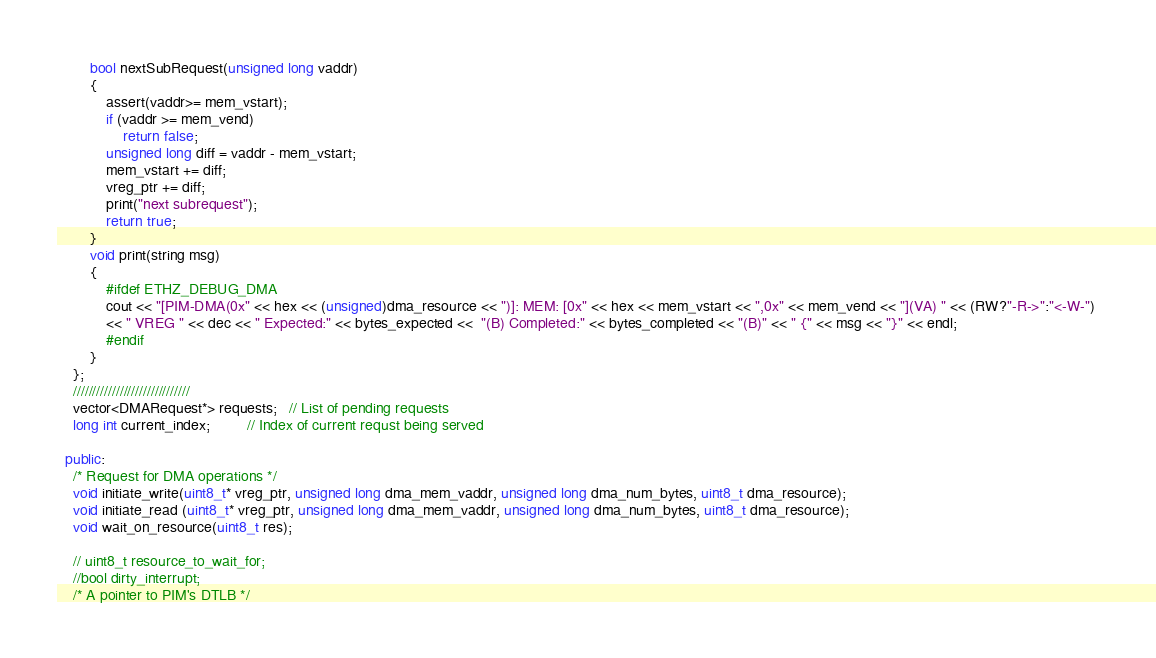Convert code to text. <code><loc_0><loc_0><loc_500><loc_500><_C++_>        bool nextSubRequest(unsigned long vaddr)
        {
            assert(vaddr>= mem_vstart);
            if (vaddr >= mem_vend)
                return false;
            unsigned long diff = vaddr - mem_vstart;
            mem_vstart += diff;
            vreg_ptr += diff;
            print("next subrequest");
            return true;
        }
        void print(string msg)
        {
            #ifdef ETHZ_DEBUG_DMA
            cout << "[PIM-DMA(0x" << hex << (unsigned)dma_resource << ")]: MEM: [0x" << hex << mem_vstart << ",0x" << mem_vend << "](VA) " << (RW?"-R->":"<-W-") 
            << " VREG " << dec << " Expected:" << bytes_expected <<  "(B) Completed:" << bytes_completed << "(B)" << " {" << msg << "}" << endl;
            #endif
        }
    };
    //////////////////////////////
    vector<DMARequest*> requests;   // List of pending requests
    long int current_index;         // Index of current requst being served

  public:
    /* Request for DMA operations */
    void initiate_write(uint8_t* vreg_ptr, unsigned long dma_mem_vaddr, unsigned long dma_num_bytes, uint8_t dma_resource);
    void initiate_read (uint8_t* vreg_ptr, unsigned long dma_mem_vaddr, unsigned long dma_num_bytes, uint8_t dma_resource);
    void wait_on_resource(uint8_t res);

    // uint8_t resource_to_wait_for;
    //bool dirty_interrupt;
    /* A pointer to PIM's DTLB */</code> 